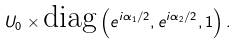<formula> <loc_0><loc_0><loc_500><loc_500>U _ { 0 } \times \text {diag} \left ( e ^ { i \alpha _ { 1 } / 2 } , e ^ { i \alpha _ { 2 } / 2 } , 1 \right ) .</formula> 